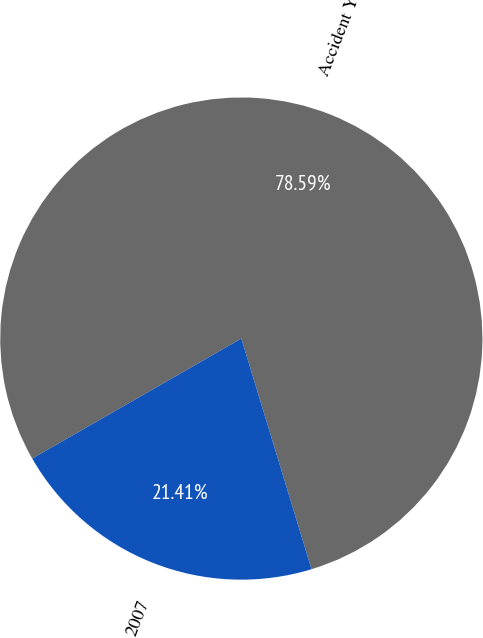<chart> <loc_0><loc_0><loc_500><loc_500><pie_chart><fcel>Accident Year<fcel>2007<nl><fcel>78.59%<fcel>21.41%<nl></chart> 